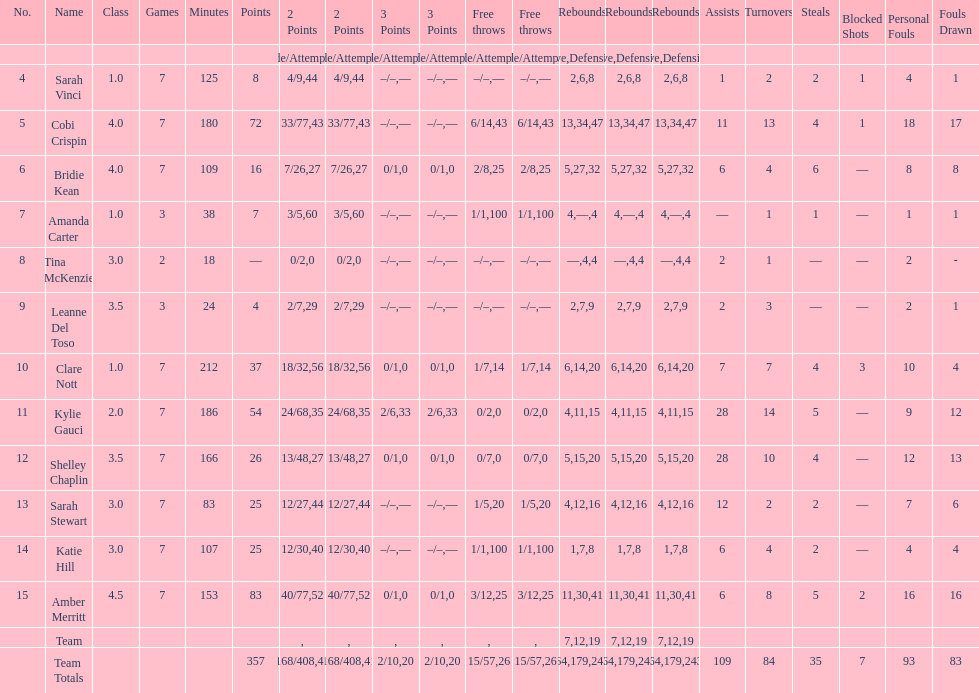Who holds the record for the most steals in comparison to other players? Bridie Kean. 